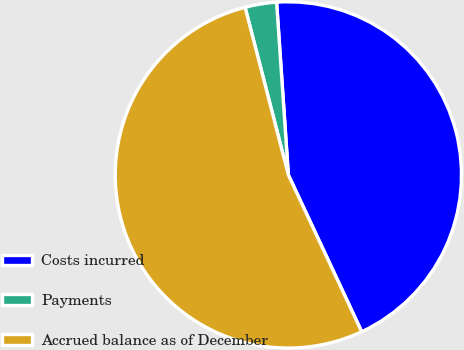Convert chart to OTSL. <chart><loc_0><loc_0><loc_500><loc_500><pie_chart><fcel>Costs incurred<fcel>Payments<fcel>Accrued balance as of December<nl><fcel>44.12%<fcel>2.94%<fcel>52.94%<nl></chart> 